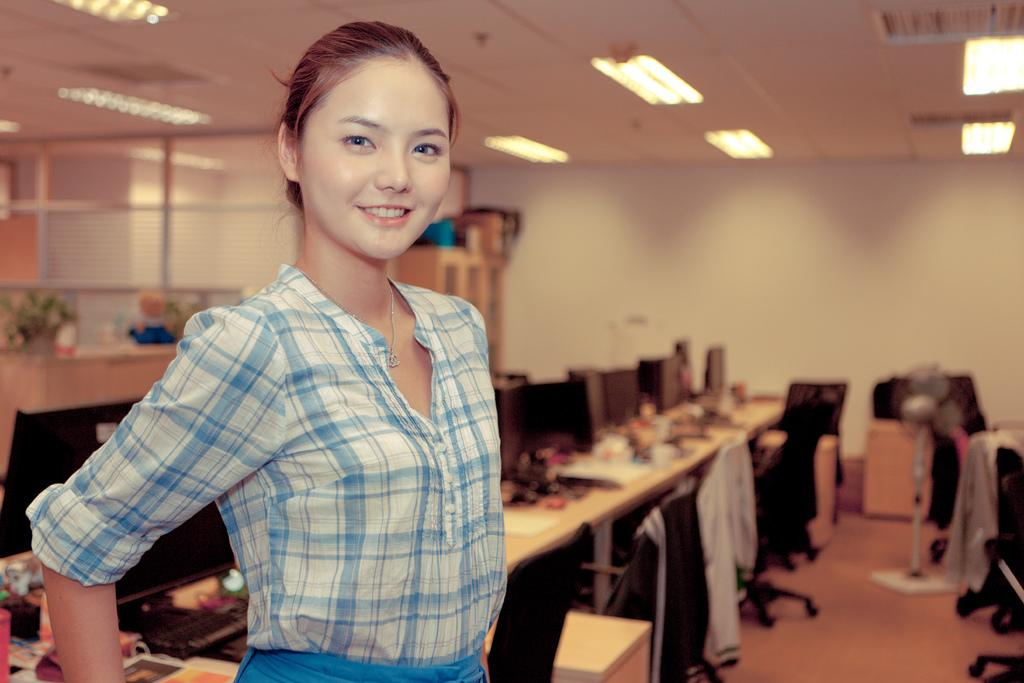Who is present in the image? There is a woman in the image. What is the woman's expression? The woman is smiling. What can be seen behind the woman? There are monitors visible behind the woman. What else is on the table besides the monitors? There are other things on the table. What type of furniture is in the image? There are chairs in the image. What can be seen illuminating the scene? There are lights in the image. What type of jam is the woman spreading on the toast in the image? There is no toast or jam present in the image; it features a woman with a smiling expression and monitors behind her. 